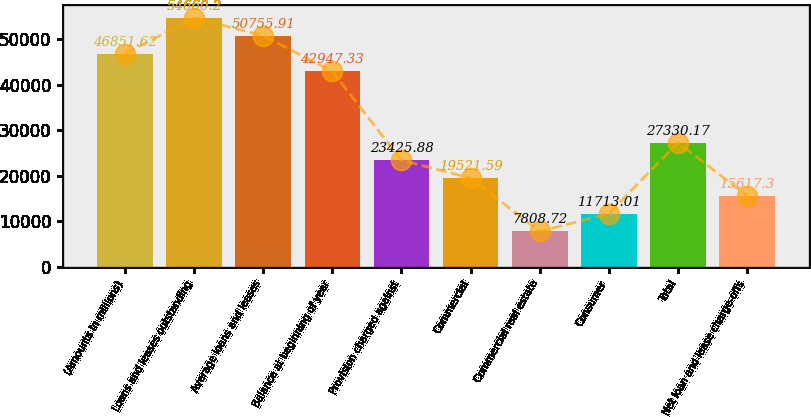Convert chart. <chart><loc_0><loc_0><loc_500><loc_500><bar_chart><fcel>(Amounts in millions)<fcel>Loans and leases outstanding<fcel>Average loans and leases<fcel>Balance at beginning of year<fcel>Provision charged against<fcel>Commercial<fcel>Commercial real estate<fcel>Consumer<fcel>Total<fcel>Net loan and lease charge-offs<nl><fcel>46851.6<fcel>54660.2<fcel>50755.9<fcel>42947.3<fcel>23425.9<fcel>19521.6<fcel>7808.72<fcel>11713<fcel>27330.2<fcel>15617.3<nl></chart> 